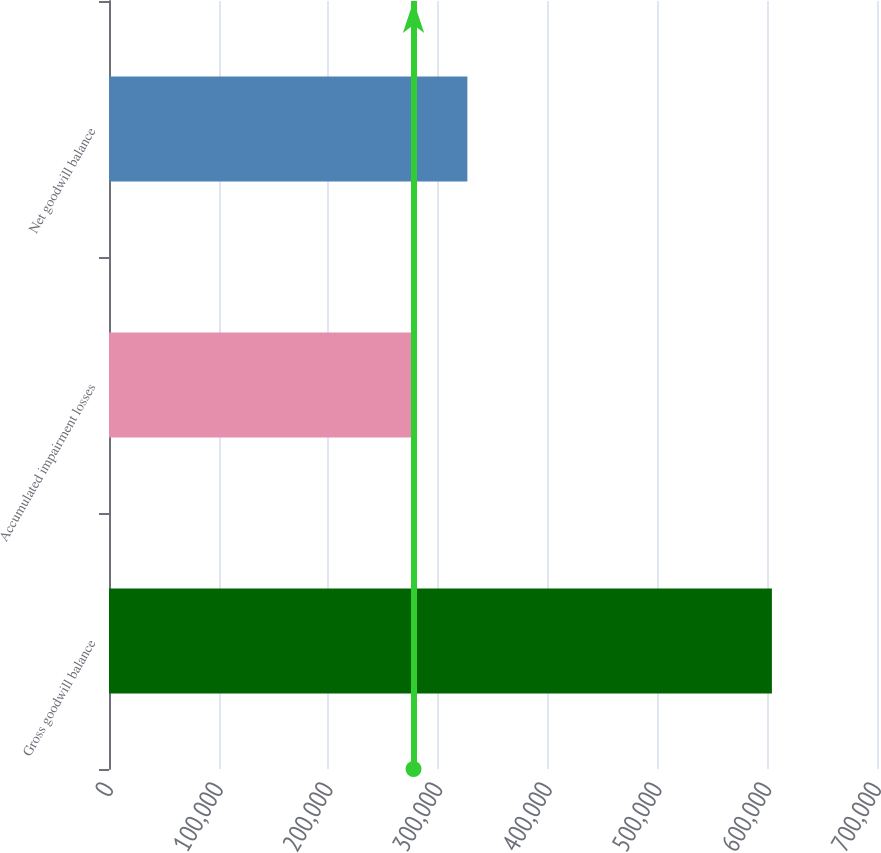<chart> <loc_0><loc_0><loc_500><loc_500><bar_chart><fcel>Gross goodwill balance<fcel>Accumulated impairment losses<fcel>Net goodwill balance<nl><fcel>604205<fcel>277570<fcel>326635<nl></chart> 